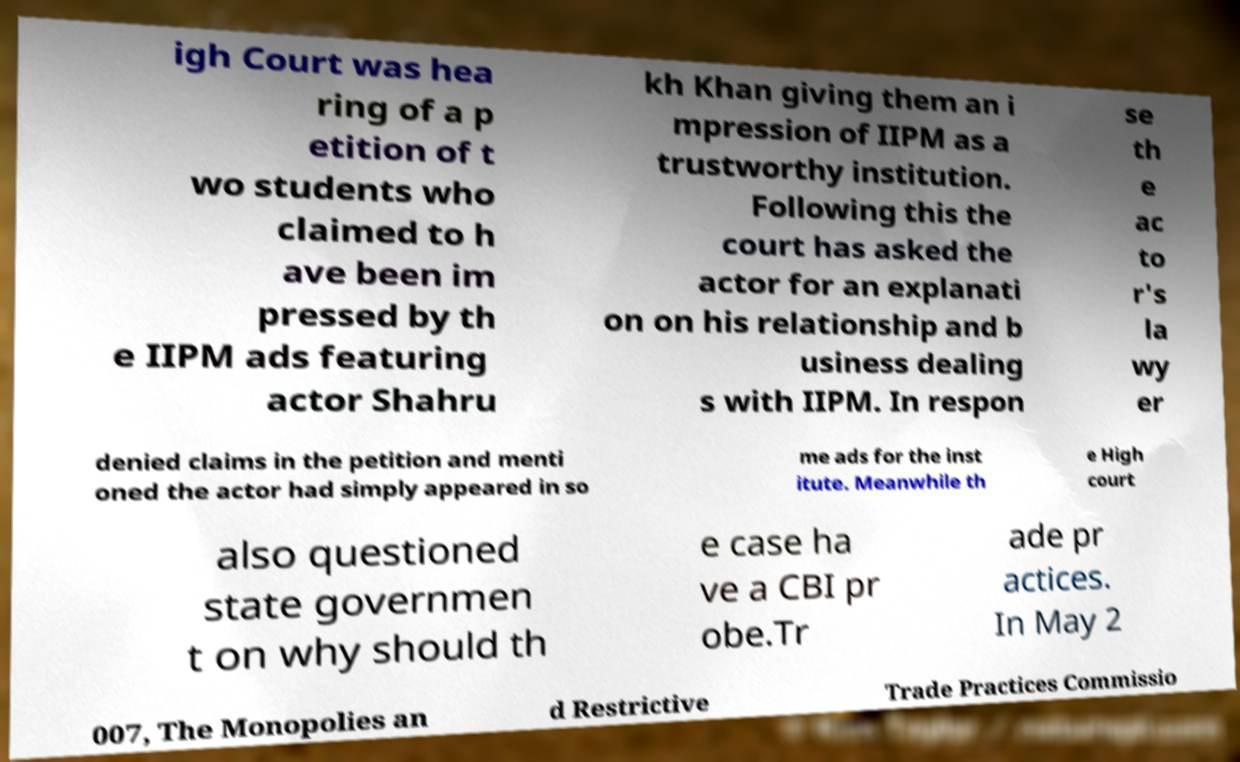For documentation purposes, I need the text within this image transcribed. Could you provide that? igh Court was hea ring of a p etition of t wo students who claimed to h ave been im pressed by th e IIPM ads featuring actor Shahru kh Khan giving them an i mpression of IIPM as a trustworthy institution. Following this the court has asked the actor for an explanati on on his relationship and b usiness dealing s with IIPM. In respon se th e ac to r's la wy er denied claims in the petition and menti oned the actor had simply appeared in so me ads for the inst itute. Meanwhile th e High court also questioned state governmen t on why should th e case ha ve a CBI pr obe.Tr ade pr actices. In May 2 007, The Monopolies an d Restrictive Trade Practices Commissio 